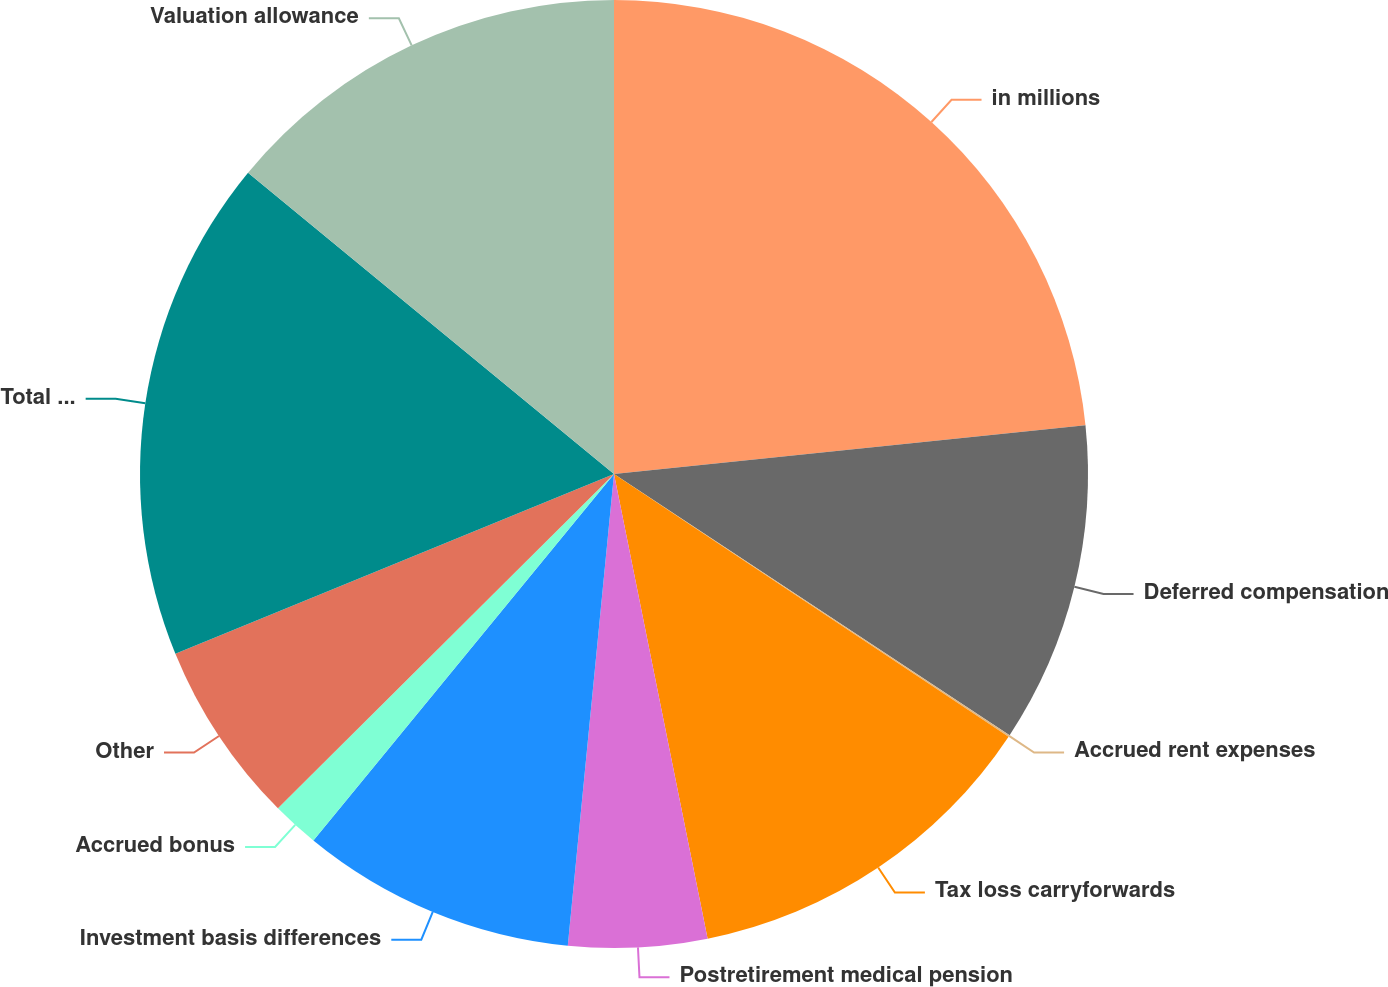<chart> <loc_0><loc_0><loc_500><loc_500><pie_chart><fcel>in millions<fcel>Deferred compensation<fcel>Accrued rent expenses<fcel>Tax loss carryforwards<fcel>Postretirement medical pension<fcel>Investment basis differences<fcel>Accrued bonus<fcel>Other<fcel>Total deferred tax assets<fcel>Valuation allowance<nl><fcel>23.36%<fcel>10.93%<fcel>0.06%<fcel>12.49%<fcel>4.72%<fcel>9.38%<fcel>1.61%<fcel>6.27%<fcel>17.15%<fcel>14.04%<nl></chart> 